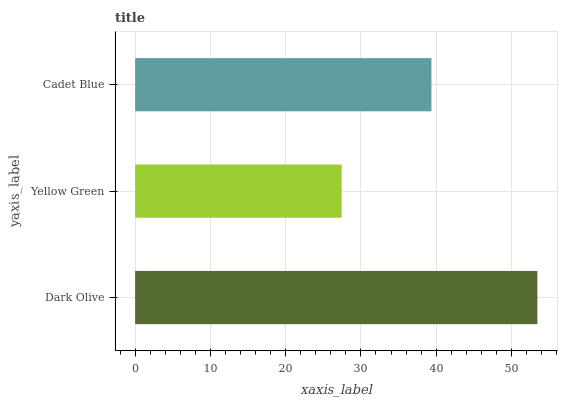Is Yellow Green the minimum?
Answer yes or no. Yes. Is Dark Olive the maximum?
Answer yes or no. Yes. Is Cadet Blue the minimum?
Answer yes or no. No. Is Cadet Blue the maximum?
Answer yes or no. No. Is Cadet Blue greater than Yellow Green?
Answer yes or no. Yes. Is Yellow Green less than Cadet Blue?
Answer yes or no. Yes. Is Yellow Green greater than Cadet Blue?
Answer yes or no. No. Is Cadet Blue less than Yellow Green?
Answer yes or no. No. Is Cadet Blue the high median?
Answer yes or no. Yes. Is Cadet Blue the low median?
Answer yes or no. Yes. Is Yellow Green the high median?
Answer yes or no. No. Is Dark Olive the low median?
Answer yes or no. No. 